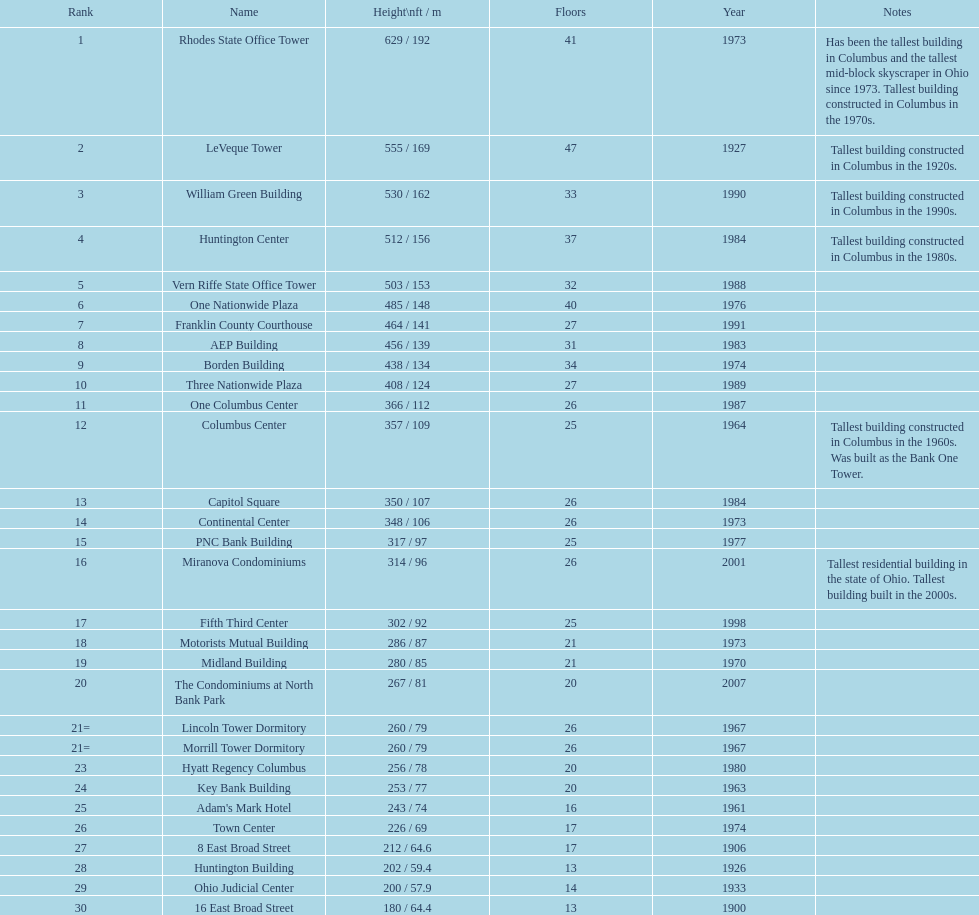Which of the highest buildings in columbus, ohio were built in the 1980s? Huntington Center, Vern Riffe State Office Tower, AEP Building, Three Nationwide Plaza, One Columbus Center, Capitol Square, Hyatt Regency Columbus. From these structures, which ones have a floor count between 26 and 31? AEP Building, Three Nationwide Plaza, One Columbus Center, Capitol Square. Of these buildings, which one has the greatest height? AEP Building. 